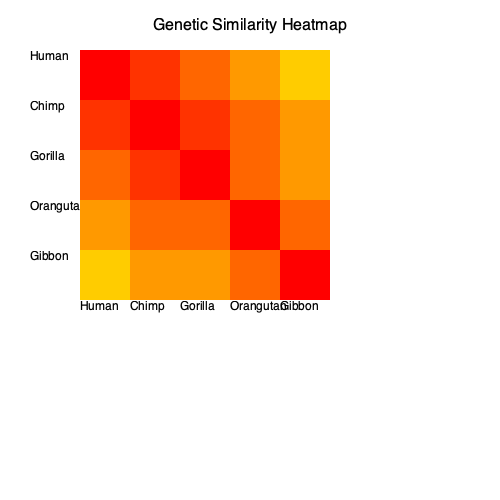Based on the genetic similarity heatmap provided, which two primate species show the highest degree of genetic similarity after humans and chimpanzees? To answer this question, we need to analyze the heatmap systematically:

1. The heatmap shows genetic similarity between five primate species: Human, Chimp, Gorilla, Orangutan, and Gibbon.

2. The color intensity represents the degree of genetic similarity, with darker red indicating higher similarity.

3. We can observe that:
   a. Humans and chimps have the darkest red square (excluding self-comparisons), indicating the highest similarity.
   b. The next darkest red square is between humans and gorillas, and between chimps and gorillas.

4. To confirm this observation, we can compare the color intensities:
   - Human-Chimp: Darkest red (#FF3300)
   - Human-Gorilla: Second darkest red (#FF6600)
   - Chimp-Gorilla: Second darkest red (#FF6600)
   - All other comparisons have lighter shades of red

5. Therefore, after humans and chimpanzees, the next highest degree of genetic similarity is between humans and gorillas, and between chimpanzees and gorillas.

6. Since gorillas are involved in both of these next-highest similarity pairs, we can conclude that gorillas are the third most genetically similar species in this group, after humans and chimpanzees.
Answer: Humans and gorillas, and chimpanzees and gorillas 